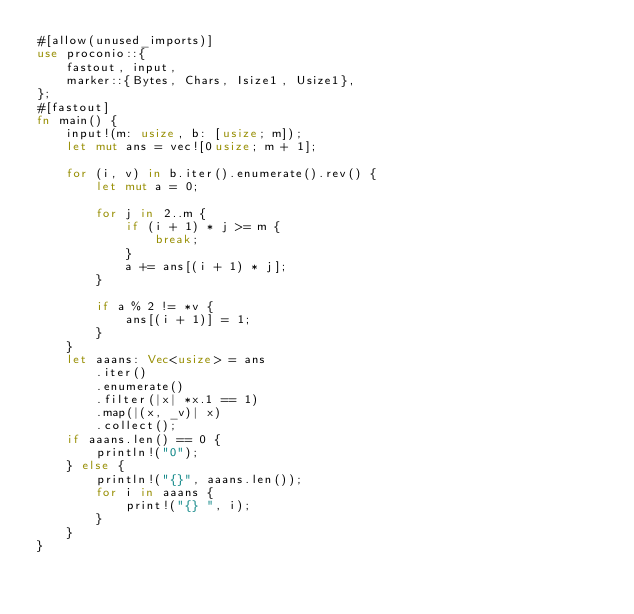<code> <loc_0><loc_0><loc_500><loc_500><_Rust_>#[allow(unused_imports)]
use proconio::{
    fastout, input,
    marker::{Bytes, Chars, Isize1, Usize1},
};
#[fastout]
fn main() {
    input!(m: usize, b: [usize; m]);
    let mut ans = vec![0usize; m + 1];

    for (i, v) in b.iter().enumerate().rev() {
        let mut a = 0;

        for j in 2..m {
            if (i + 1) * j >= m {
                break;
            }
            a += ans[(i + 1) * j];
        }

        if a % 2 != *v {
            ans[(i + 1)] = 1;
        }
    }
    let aaans: Vec<usize> = ans
        .iter()
        .enumerate()
        .filter(|x| *x.1 == 1)
        .map(|(x, _v)| x)
        .collect();
    if aaans.len() == 0 {
        println!("0");
    } else {
        println!("{}", aaans.len());
        for i in aaans {
            print!("{} ", i);
        }
    }
}
</code> 